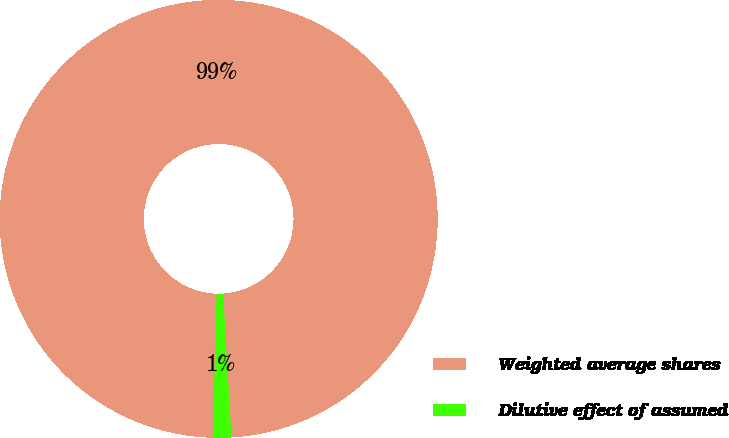<chart> <loc_0><loc_0><loc_500><loc_500><pie_chart><fcel>Weighted average shares<fcel>Dilutive effect of assumed<nl><fcel>98.65%<fcel>1.35%<nl></chart> 